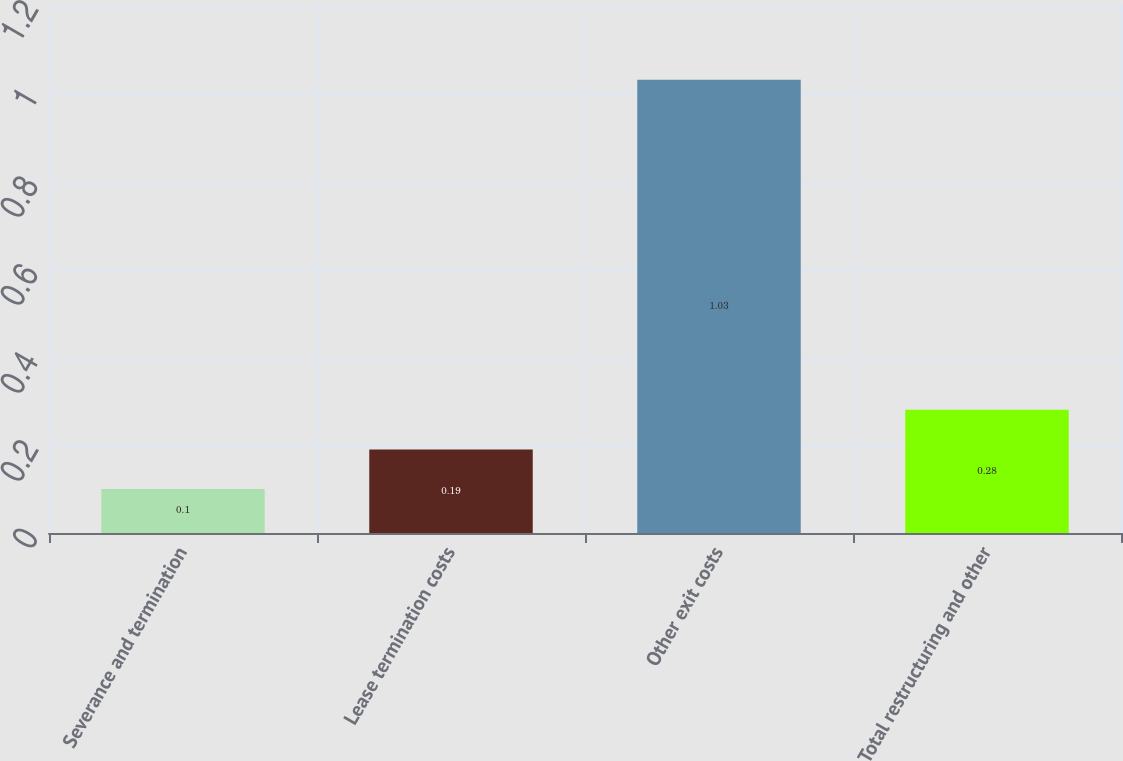Convert chart to OTSL. <chart><loc_0><loc_0><loc_500><loc_500><bar_chart><fcel>Severance and termination<fcel>Lease termination costs<fcel>Other exit costs<fcel>Total restructuring and other<nl><fcel>0.1<fcel>0.19<fcel>1.03<fcel>0.28<nl></chart> 